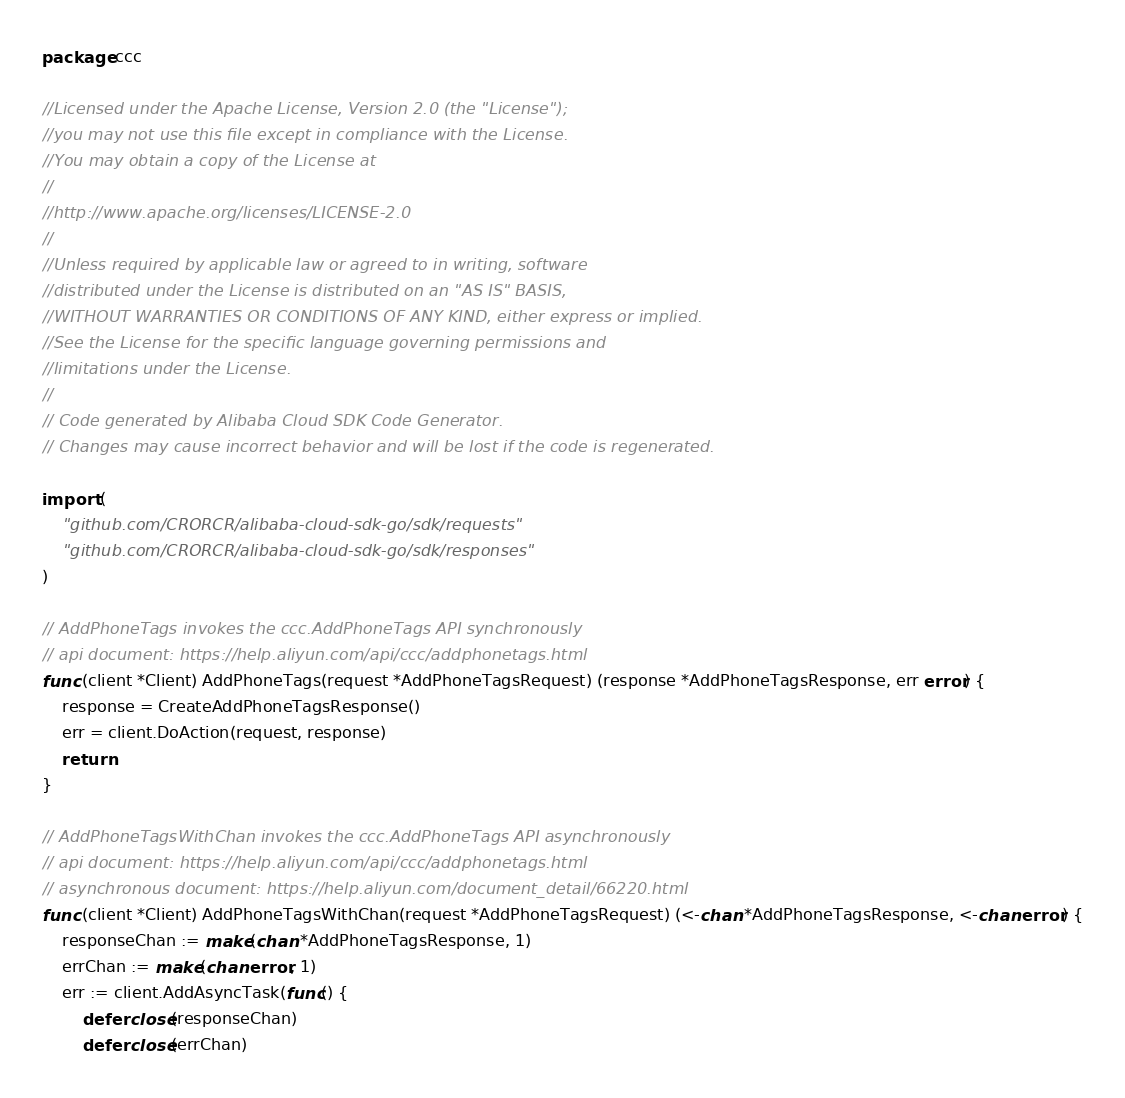<code> <loc_0><loc_0><loc_500><loc_500><_Go_>package ccc

//Licensed under the Apache License, Version 2.0 (the "License");
//you may not use this file except in compliance with the License.
//You may obtain a copy of the License at
//
//http://www.apache.org/licenses/LICENSE-2.0
//
//Unless required by applicable law or agreed to in writing, software
//distributed under the License is distributed on an "AS IS" BASIS,
//WITHOUT WARRANTIES OR CONDITIONS OF ANY KIND, either express or implied.
//See the License for the specific language governing permissions and
//limitations under the License.
//
// Code generated by Alibaba Cloud SDK Code Generator.
// Changes may cause incorrect behavior and will be lost if the code is regenerated.

import (
	"github.com/CRORCR/alibaba-cloud-sdk-go/sdk/requests"
	"github.com/CRORCR/alibaba-cloud-sdk-go/sdk/responses"
)

// AddPhoneTags invokes the ccc.AddPhoneTags API synchronously
// api document: https://help.aliyun.com/api/ccc/addphonetags.html
func (client *Client) AddPhoneTags(request *AddPhoneTagsRequest) (response *AddPhoneTagsResponse, err error) {
	response = CreateAddPhoneTagsResponse()
	err = client.DoAction(request, response)
	return
}

// AddPhoneTagsWithChan invokes the ccc.AddPhoneTags API asynchronously
// api document: https://help.aliyun.com/api/ccc/addphonetags.html
// asynchronous document: https://help.aliyun.com/document_detail/66220.html
func (client *Client) AddPhoneTagsWithChan(request *AddPhoneTagsRequest) (<-chan *AddPhoneTagsResponse, <-chan error) {
	responseChan := make(chan *AddPhoneTagsResponse, 1)
	errChan := make(chan error, 1)
	err := client.AddAsyncTask(func() {
		defer close(responseChan)
		defer close(errChan)</code> 